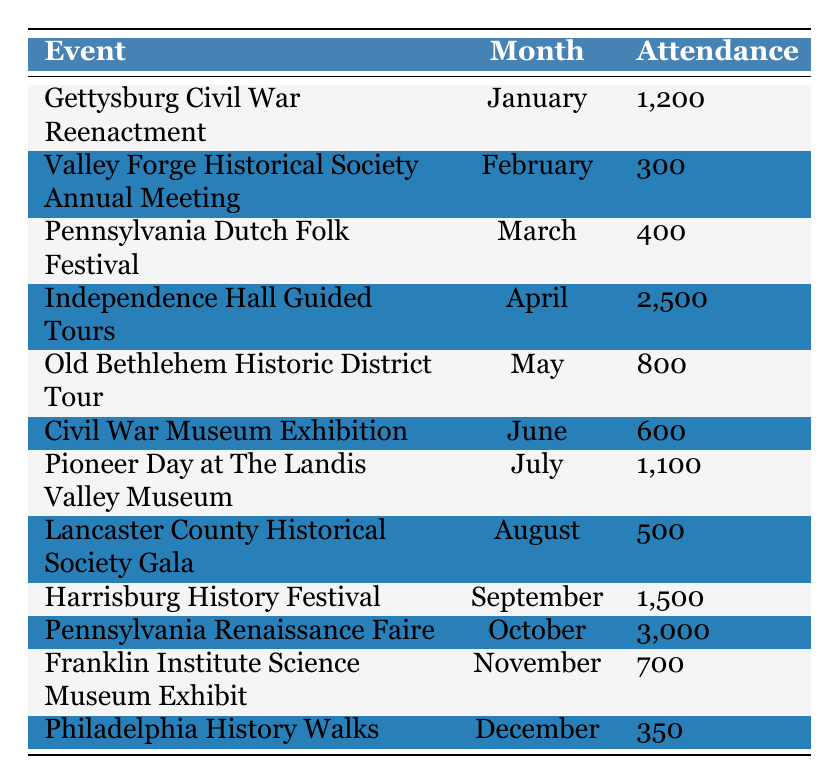What was the attendance at the Independence Hall Guided Tours in April? The table shows that the attendance for the Independence Hall Guided Tours in April was 2,500.
Answer: 2,500 Which event had the lowest attendance and what was that number? Looking at the table, the event with the lowest attendance is the Valley Forge Historical Society Annual Meeting in February with an attendance of 300.
Answer: 300 What is the total attendance for events from July to October? The events from July to October are: Pioneer Day at The Landis Valley Museum (1,100), Lancaster County Historical Society Gala (500), Harrisburg History Festival (1,500), and Pennsylvania Renaissance Faire (3,000). Adding these numbers gives 1,100 + 500 + 1,500 + 3,000 = 6,100.
Answer: 6,100 Did more than 1,000 people attend the Gettysburg Civil War Reenactment? Referring to the table, the attendance for the Gettysburg Civil War Reenactment is 1,200. Since 1,200 is greater than 1,000, the statement is true.
Answer: Yes What are the average attendances for historical events in the first and second halves of the year? For the first half (January to June), attendance amounts are: 1,200 (January), 300 (February), 400 (March), 2,500 (April), 800 (May), and 600 (June). The total is 1,200 + 300 + 400 + 2,500 + 800 + 600 = 5,800. Dividing by 6 gives an average of 5,800 / 6 = 966.67. For the second half (July to December), attendance amounts are: 1,100 (July), 500 (August), 1,500 (September), 3,000 (October), 700 (November), and 350 (December). The total is 1,100 + 500 + 1,500 + 3,000 + 700 + 350 = 7,150. Dividing by 6 gives an average of 7,150 / 6 = 1,191.67.
Answer: First half: 966.67; Second half: 1,191.67 Which month had more attendance, October or April? October had attendance of 3,000 for the Pennsylvania Renaissance Faire, while April had 2,500 for Independence Hall Guided Tours. Comparing these numbers, 3,000 is greater than 2,500, hence October had more attendance than April.
Answer: October How many events had an attendance of over 1,000? By scanning the table, the events with attendance over 1,000 are: Gettysburg Civil War Reenactment (1,200), Independence Hall Guided Tours (2,500), Pioneer Day at The Landis Valley Museum (1,100), Harrisburg History Festival (1,500), and Pennsylvania Renaissance Faire (3,000). This sums to a total of 5 events with over 1,000 attendees.
Answer: 5 